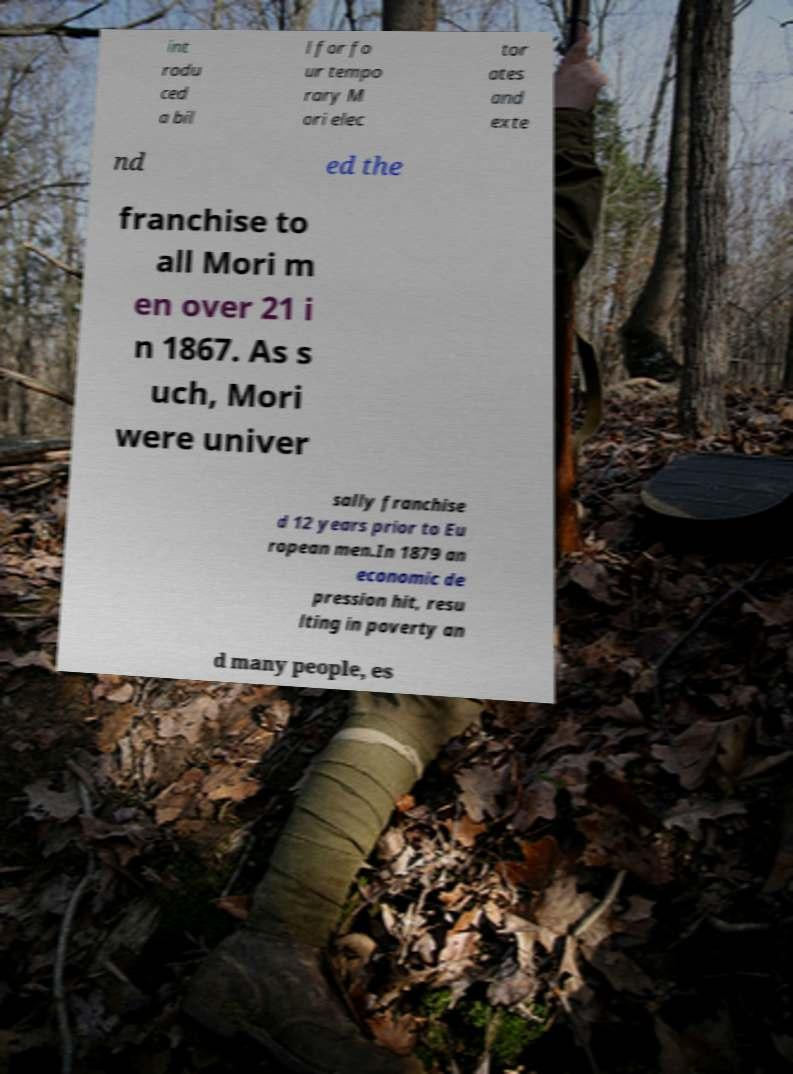Please identify and transcribe the text found in this image. int rodu ced a bil l for fo ur tempo rary M ori elec tor ates and exte nd ed the franchise to all Mori m en over 21 i n 1867. As s uch, Mori were univer sally franchise d 12 years prior to Eu ropean men.In 1879 an economic de pression hit, resu lting in poverty an d many people, es 